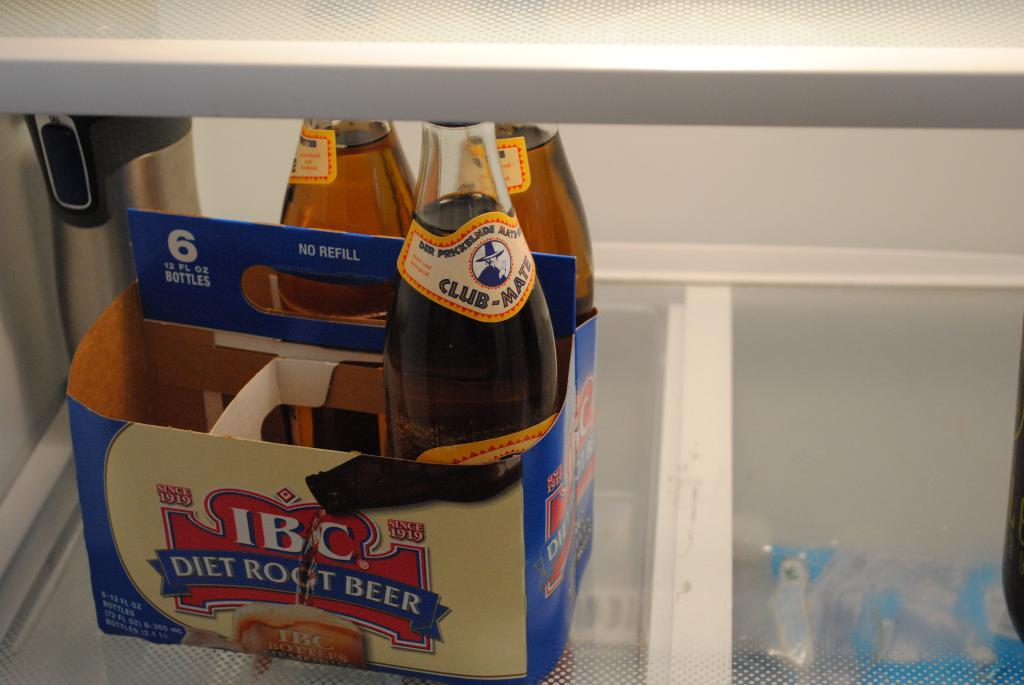What object is present in the image that might be used for storage? There is a box in the image. What is inside the box in the image? The box contains three wine bottles. What type of cheese is being served at the camp competition in the image? There is no cheese, camp, or competition present in the image; it only features a box containing three wine bottles. 